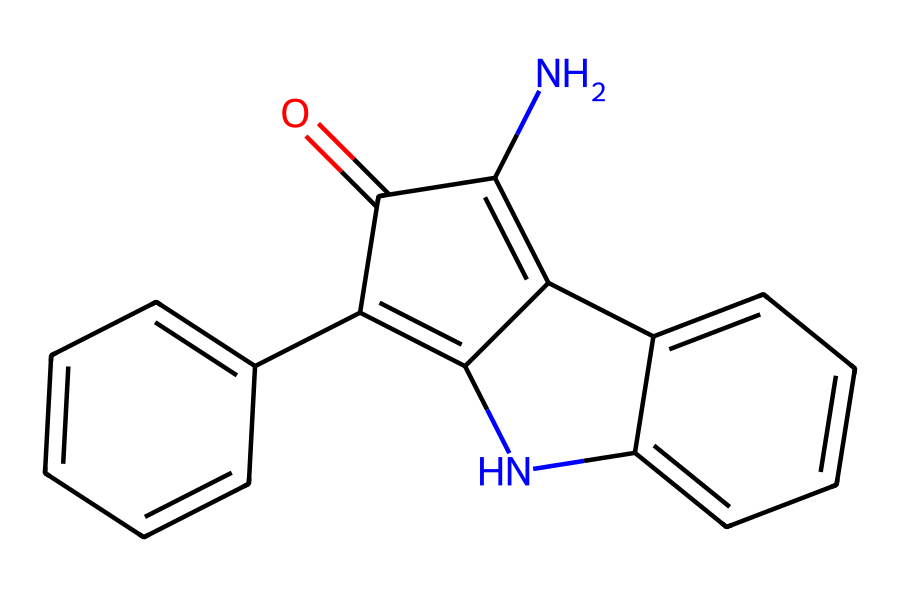What is the name of the natural dye represented by this structure? The SMILES representation corresponds to indigo, a well-known natural dye used in textiles derived from plants, primarily from the genus Indigofera.
Answer: indigo How many nitrogen atoms are present in the structure? By examining the SMILES notation, there are two nitrogen atoms indicated by 'N', which are part of the indole structure in indigo.
Answer: two What is the total number of carbon atoms in the chemical structure? In the structure, counting the 'C' symbols in the SMILES notation reveals that there are 16 carbon atoms.
Answer: sixteen What type of bonding can be inferred from the presence of double bonds in the structure? The presence of '=' signs in the SMILES indicates double bonds between carbon atoms, which suggests unsaturation in the molecule, giving it potential reactivity and color characteristics.
Answer: double bonds Is this dye considered eco-friendly, and why? Indigo is considered eco-friendly due to its natural origin from plants and lower environmental impact compared to synthetic dyes, which often contain toxic substances.
Answer: eco-friendly How does the structure contribute to the color properties of indigo? The conjugated system of double bonds and the planar structure allows for extensive electron delocalization, resulting in the rich blue color characteristic of indigo dye.
Answer: electron delocalization What functional groups are indicated in the structure? The structure primarily features a carbonyl group (C=O) as part of the indole and unsaturated linkages, which are key to its dyeing properties.
Answer: carbonyl group 